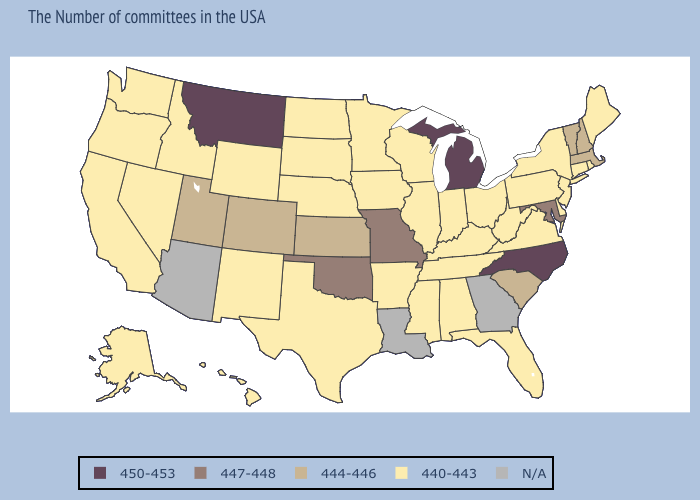What is the highest value in states that border Arkansas?
Short answer required. 447-448. Which states have the highest value in the USA?
Answer briefly. North Carolina, Michigan, Montana. Name the states that have a value in the range N/A?
Be succinct. Georgia, Louisiana, Arizona. Name the states that have a value in the range 444-446?
Give a very brief answer. Massachusetts, New Hampshire, Vermont, South Carolina, Kansas, Colorado, Utah. Name the states that have a value in the range N/A?
Write a very short answer. Georgia, Louisiana, Arizona. Name the states that have a value in the range 440-443?
Keep it brief. Maine, Rhode Island, Connecticut, New York, New Jersey, Delaware, Pennsylvania, Virginia, West Virginia, Ohio, Florida, Kentucky, Indiana, Alabama, Tennessee, Wisconsin, Illinois, Mississippi, Arkansas, Minnesota, Iowa, Nebraska, Texas, South Dakota, North Dakota, Wyoming, New Mexico, Idaho, Nevada, California, Washington, Oregon, Alaska, Hawaii. Which states have the lowest value in the USA?
Quick response, please. Maine, Rhode Island, Connecticut, New York, New Jersey, Delaware, Pennsylvania, Virginia, West Virginia, Ohio, Florida, Kentucky, Indiana, Alabama, Tennessee, Wisconsin, Illinois, Mississippi, Arkansas, Minnesota, Iowa, Nebraska, Texas, South Dakota, North Dakota, Wyoming, New Mexico, Idaho, Nevada, California, Washington, Oregon, Alaska, Hawaii. What is the value of Nebraska?
Write a very short answer. 440-443. What is the lowest value in the South?
Short answer required. 440-443. What is the value of Florida?
Short answer required. 440-443. What is the highest value in states that border Nebraska?
Give a very brief answer. 447-448. Does the first symbol in the legend represent the smallest category?
Concise answer only. No. 